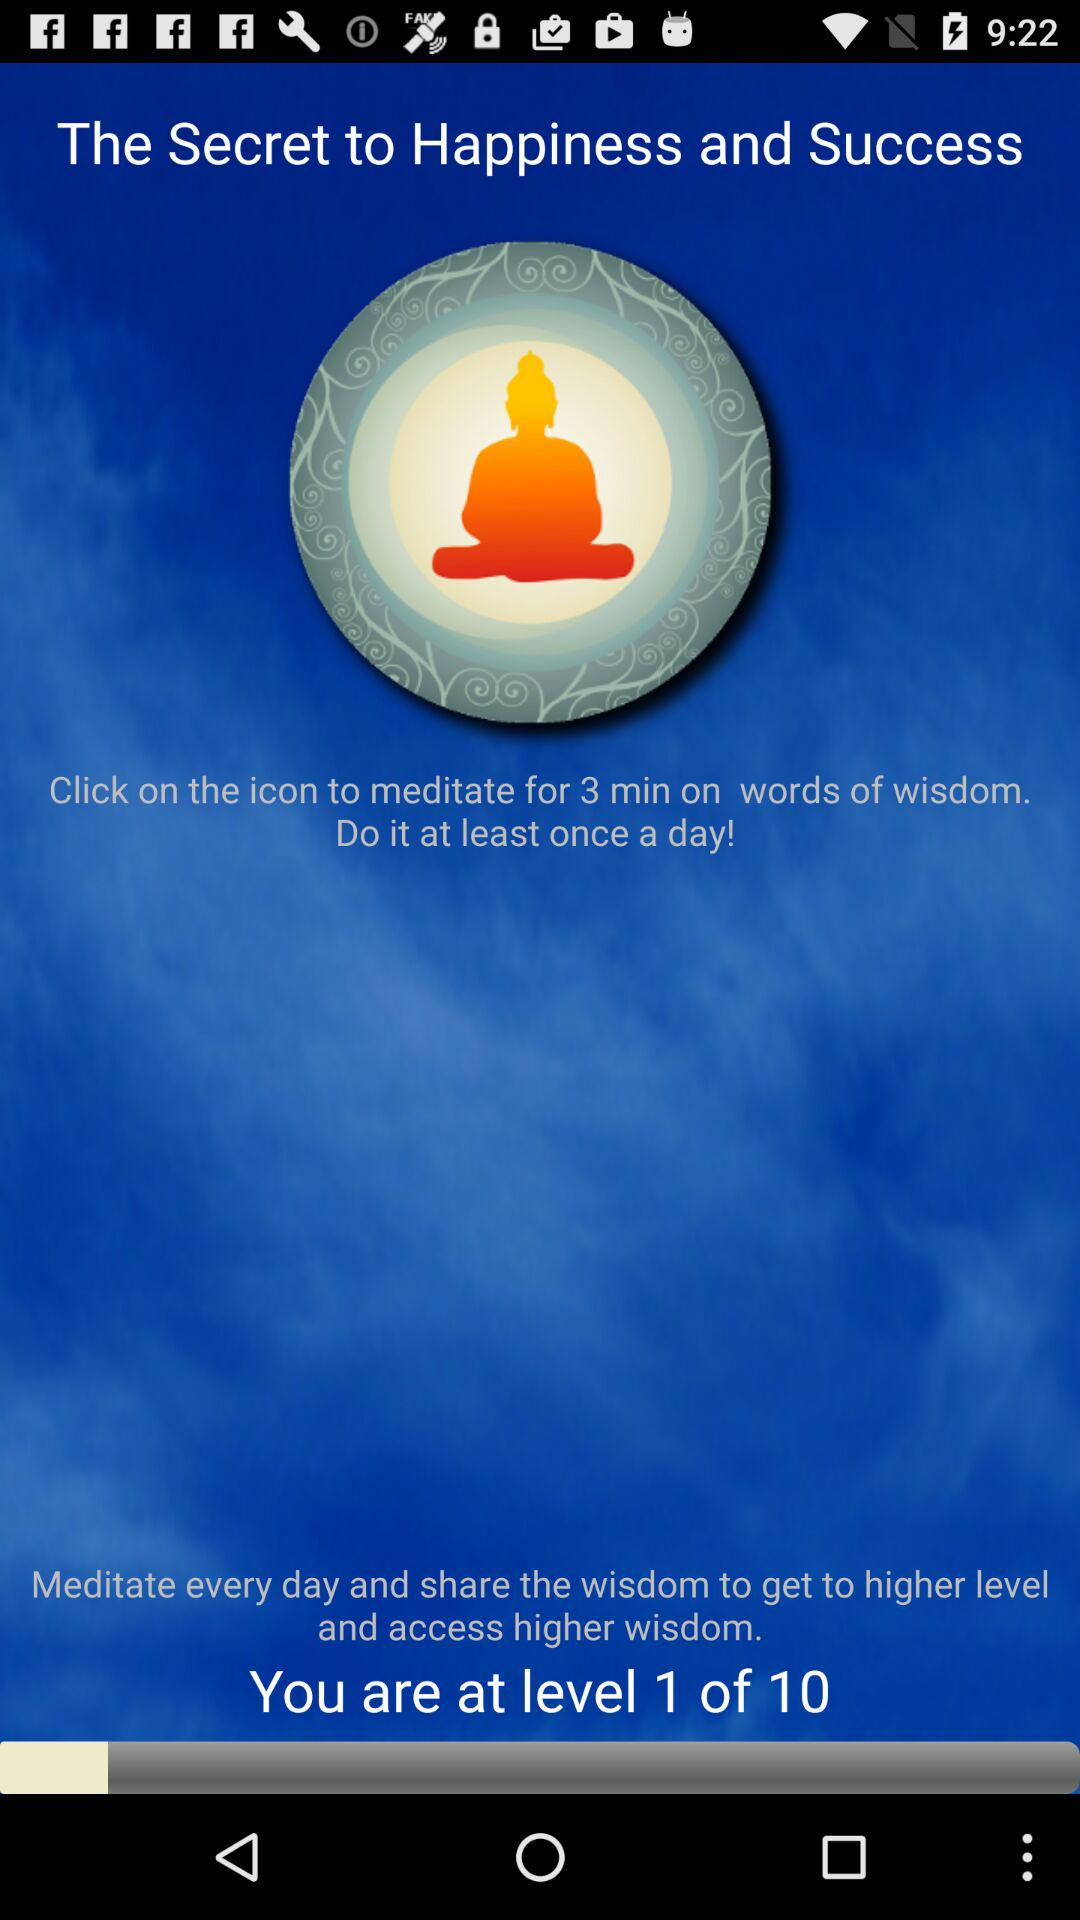What is the total count of "Level"? The total count of "Level" is 10. 